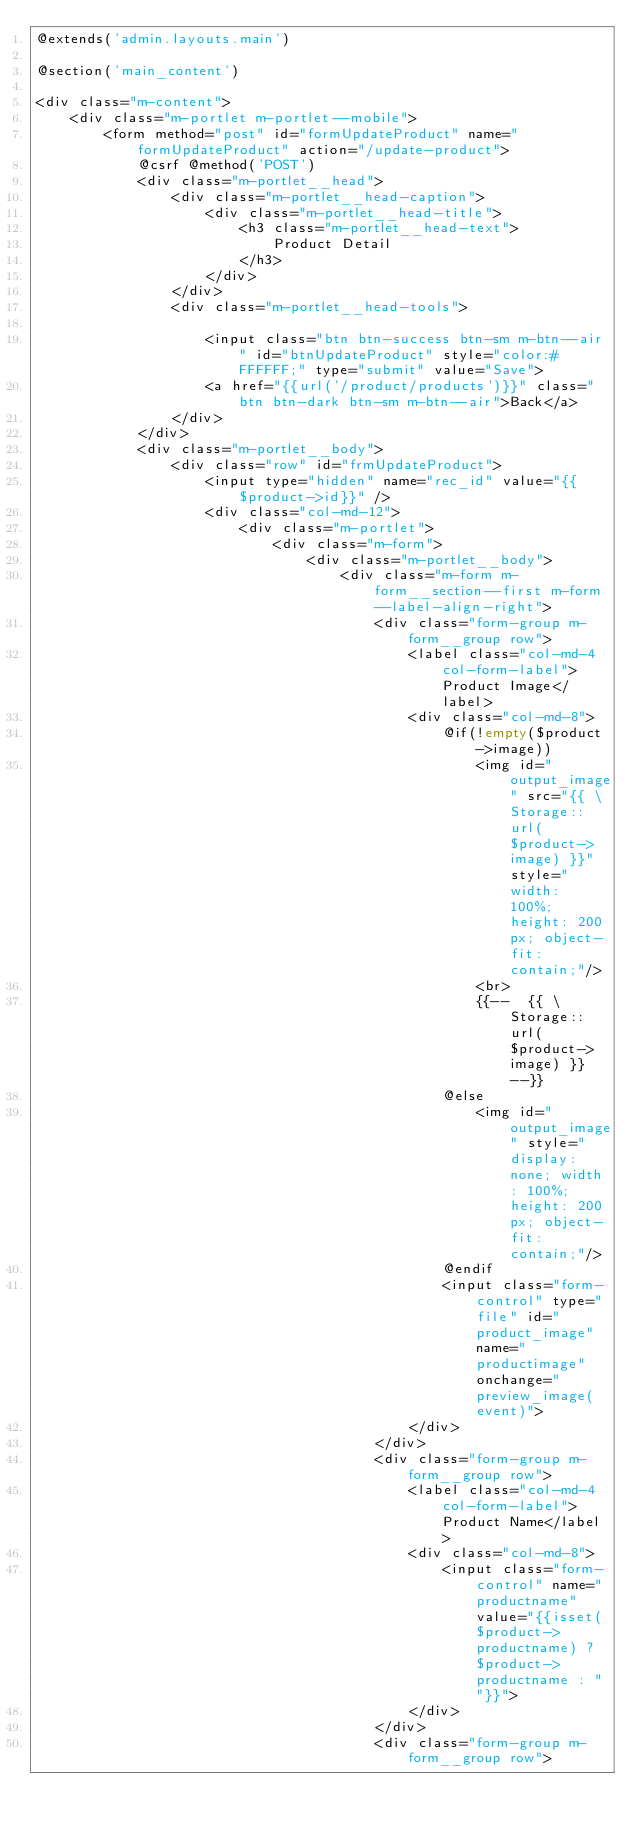<code> <loc_0><loc_0><loc_500><loc_500><_PHP_>@extends('admin.layouts.main')

@section('main_content')

<div class="m-content">
    <div class="m-portlet m-portlet--mobile">
        <form method="post" id="formUpdateProduct" name="formUpdateProduct" action="/update-product">
            @csrf @method('POST')
            <div class="m-portlet__head">
                <div class="m-portlet__head-caption">
                    <div class="m-portlet__head-title">
                        <h3 class="m-portlet__head-text">
                            Product Detail
                        </h3>
                    </div>
                </div>
                <div class="m-portlet__head-tools">
                    
                    <input class="btn btn-success btn-sm m-btn--air" id="btnUpdateProduct" style="color:#FFFFFF;" type="submit" value="Save">
                    <a href="{{url('/product/products')}}" class="btn btn-dark btn-sm m-btn--air">Back</a>
                </div>
            </div>
            <div class="m-portlet__body">
                <div class="row" id="frmUpdateProduct">
                    <input type="hidden" name="rec_id" value="{{$product->id}}" />
                    <div class="col-md-12">
                        <div class="m-portlet">
                            <div class="m-form">
                                <div class="m-portlet__body">                               
                                    <div class="m-form m-form__section--first m-form--label-align-right">
                                        <div class="form-group m-form__group row">
                                            <label class="col-md-4 col-form-label">Product Image</label>
                                            <div class="col-md-8">                                           
                                                @if(!empty($product->image))
                                                    <img id="output_image" src="{{ \Storage::url($product->image) }}" style="width: 100%; height: 200px; object-fit: contain;"/>
                                                    <br>
                                                    {{--  {{ \Storage::url($product->image) }}  --}}
                                                @else
                                                    <img id="output_image" style="display: none; width: 100%; height: 200px; object-fit: contain;"/>
                                                @endif
                                                <input class="form-control" type="file" id="product_image" name="productimage" onchange="preview_image(event)">
                                            </div>
                                        </div>
                                        <div class="form-group m-form__group row">
                                            <label class="col-md-4 col-form-label">Product Name</label>
                                            <div class="col-md-8">
                                                <input class="form-control" name="productname" value="{{isset($product->productname) ? $product->productname : ""}}">
                                            </div>
                                        </div>
                                        <div class="form-group m-form__group row"></code> 